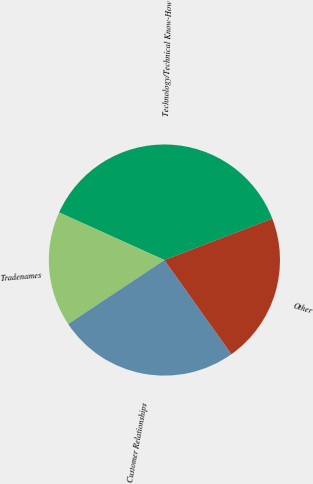Convert chart. <chart><loc_0><loc_0><loc_500><loc_500><pie_chart><fcel>Technology/Technical Know-How<fcel>Tradenames<fcel>Customer Relationships<fcel>Other<nl><fcel>37.41%<fcel>16.1%<fcel>25.5%<fcel>20.99%<nl></chart> 